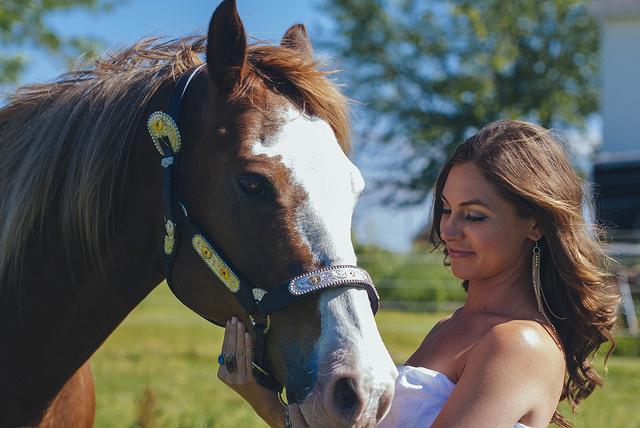How does she have her hair styled?
Answer briefly. Wavy. What color is the horse?
Answer briefly. Brown. How many animals?
Concise answer only. 1. Which animal is this?
Give a very brief answer. Horse. Does the girl have long earrings?
Write a very short answer. Yes. Do they have the same color hair?
Be succinct. Yes. Is the woman attracted to the horse?
Short answer required. Yes. Is this the countryside?
Short answer required. Yes. What color is the harness?
Concise answer only. Black. What is she seated on?
Write a very short answer. Nothing. What type of tattoo is shown?
Quick response, please. None. 